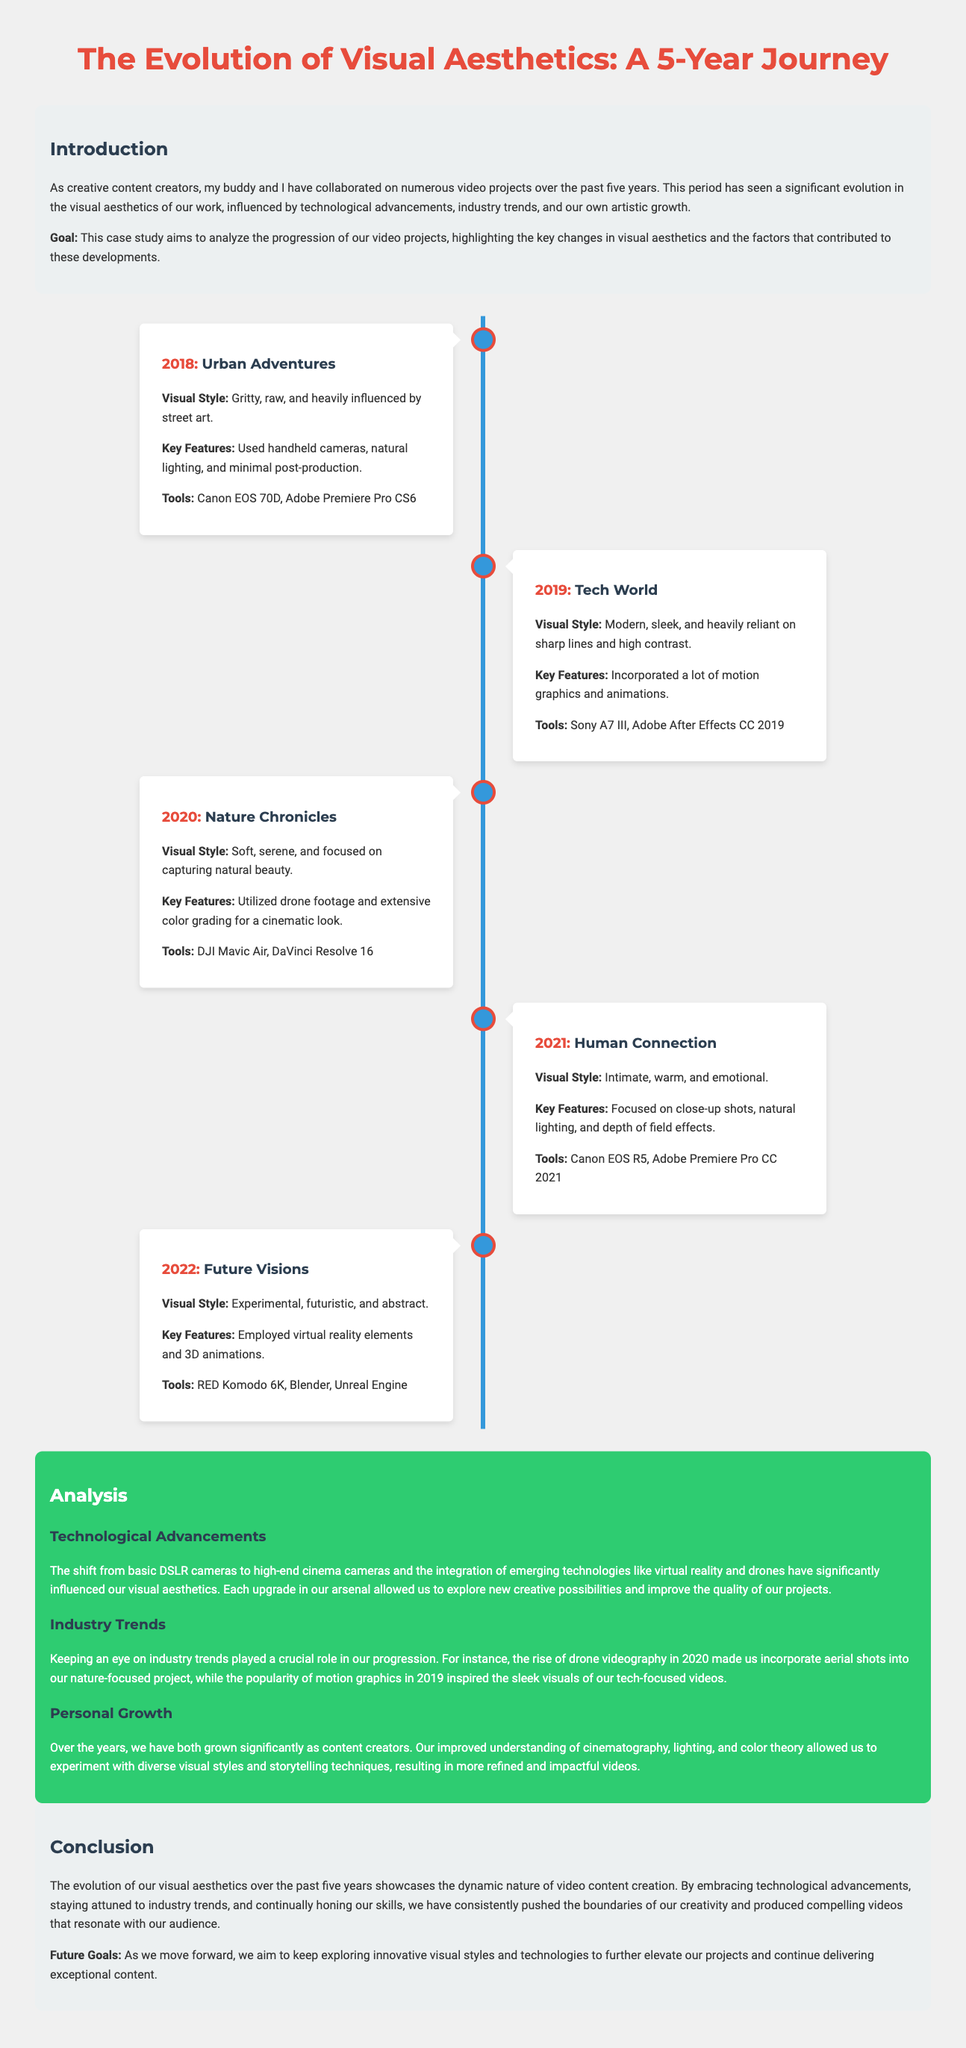what is the title of the case study? The title of the case study is explicitly stated in the document.
Answer: The Evolution of Visual Aesthetics: A 5-Year Journey which year was the project "Tech World" created? The specific year of the project is mentioned in the individual project descriptions.
Answer: 2019 what visual style is associated with the project "Nature Chronicles"? The visual style for each project is detailed in the document, specifically under each project.
Answer: Soft, serene, and focused on capturing natural beauty what tools were used for the project "Human Connection"? The document lists the tools utilized in each project, providing important details for reference.
Answer: Canon EOS R5, Adobe Premiere Pro CC 2021 which technological advancement had a significant influence in 2020? The document discusses how emerging technologies impacted visual aesthetics, particularly in that year.
Answer: Drone videography what is the main goal of the case study? The document states the goal clearly in the introduction section.
Answer: To analyze the progression of video projects in which year did the content creators employ virtual reality elements? The timeline of projects includes key developments made by the creators over the years, specifying when virtual reality was introduced.
Answer: 2022 what key feature was highlighted in the project "Future Visions"? The key features of each project are highlighted in their descriptions, outlining unique elements of the work.
Answer: Employed virtual reality elements and 3D animations 